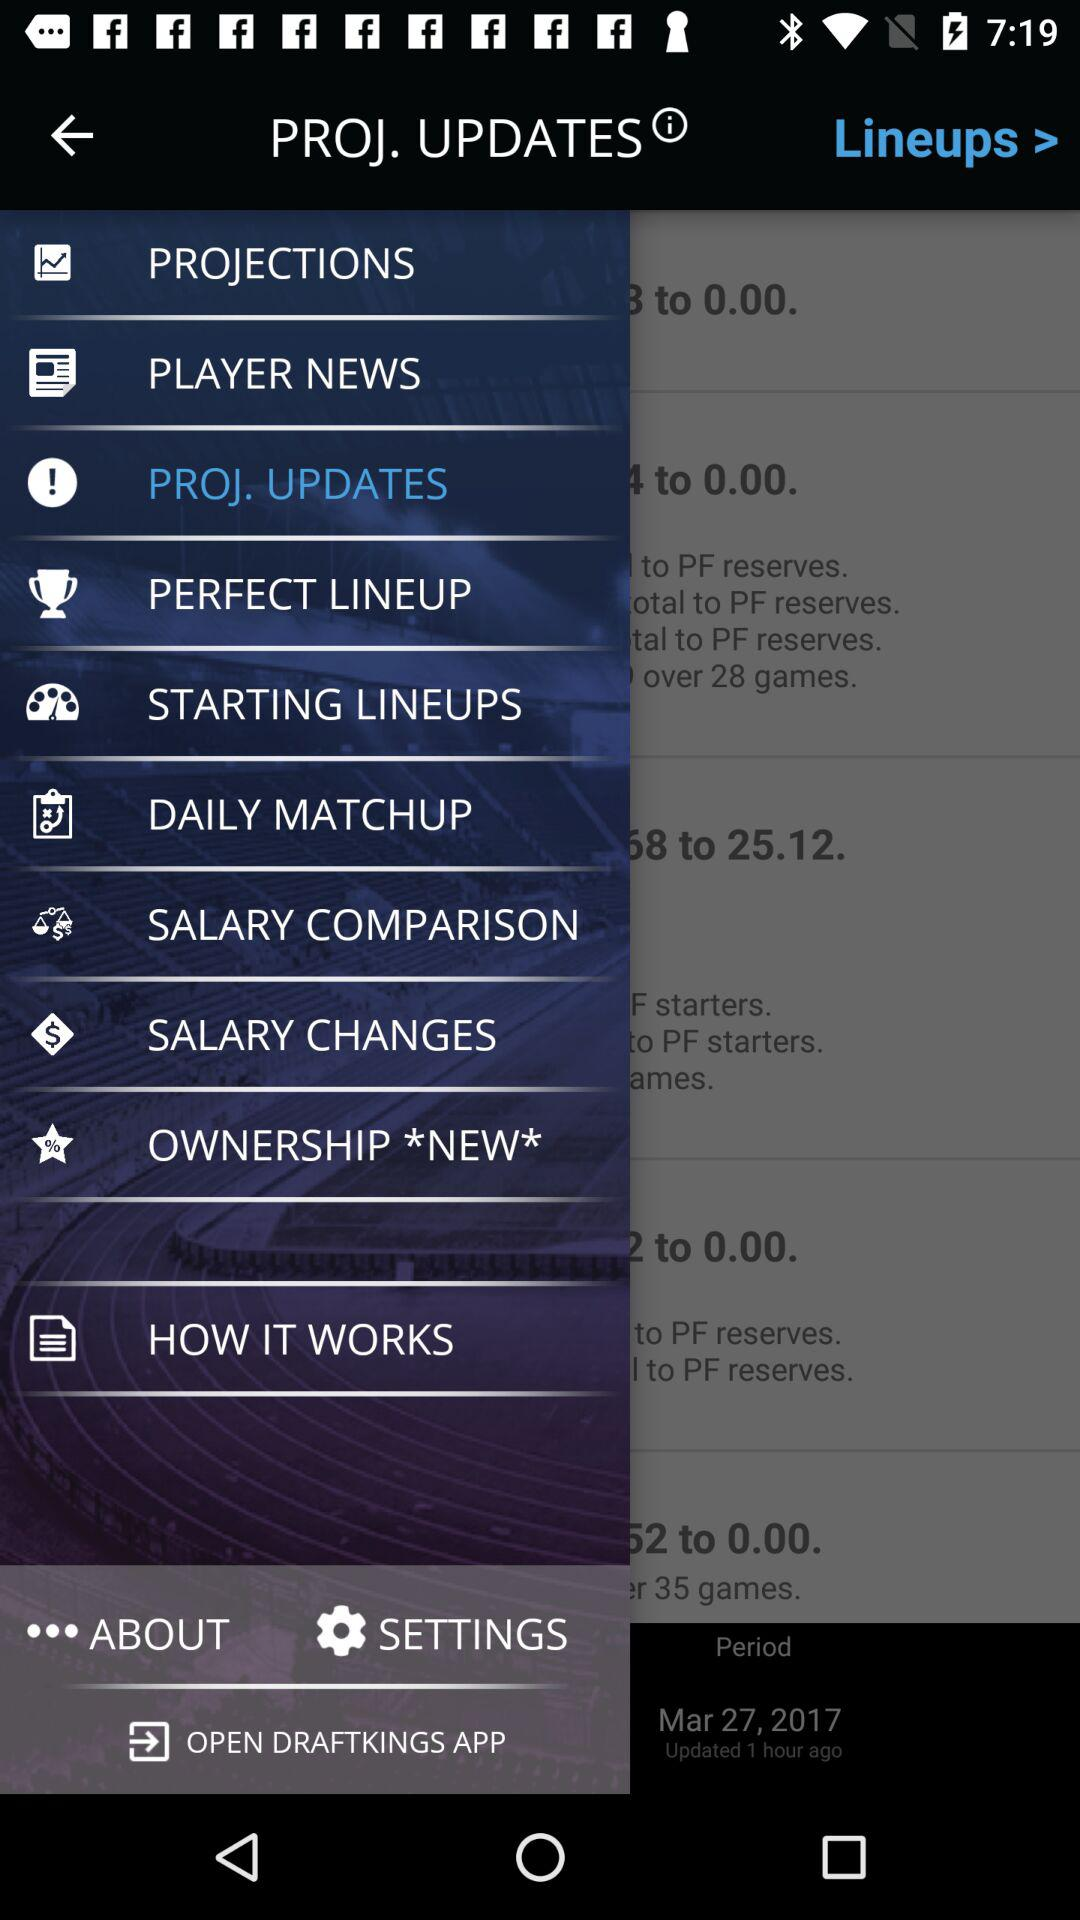What is the app name? The app name is "DRAFTKINGS". 